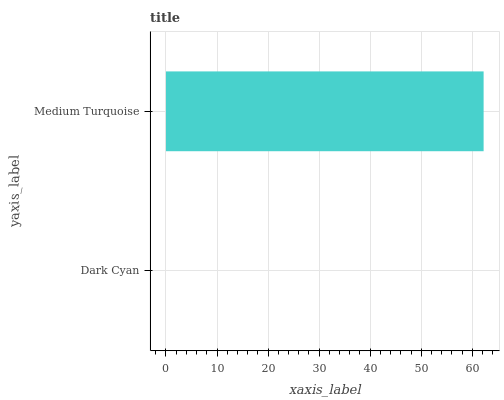Is Dark Cyan the minimum?
Answer yes or no. Yes. Is Medium Turquoise the maximum?
Answer yes or no. Yes. Is Medium Turquoise the minimum?
Answer yes or no. No. Is Medium Turquoise greater than Dark Cyan?
Answer yes or no. Yes. Is Dark Cyan less than Medium Turquoise?
Answer yes or no. Yes. Is Dark Cyan greater than Medium Turquoise?
Answer yes or no. No. Is Medium Turquoise less than Dark Cyan?
Answer yes or no. No. Is Medium Turquoise the high median?
Answer yes or no. Yes. Is Dark Cyan the low median?
Answer yes or no. Yes. Is Dark Cyan the high median?
Answer yes or no. No. Is Medium Turquoise the low median?
Answer yes or no. No. 